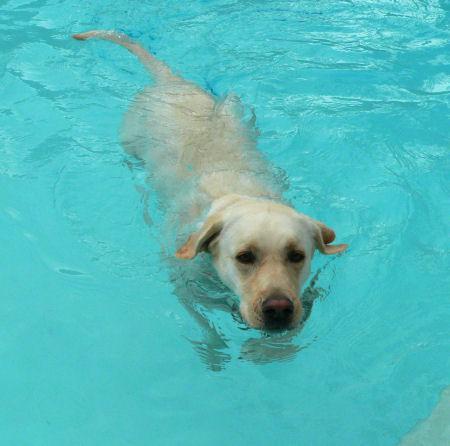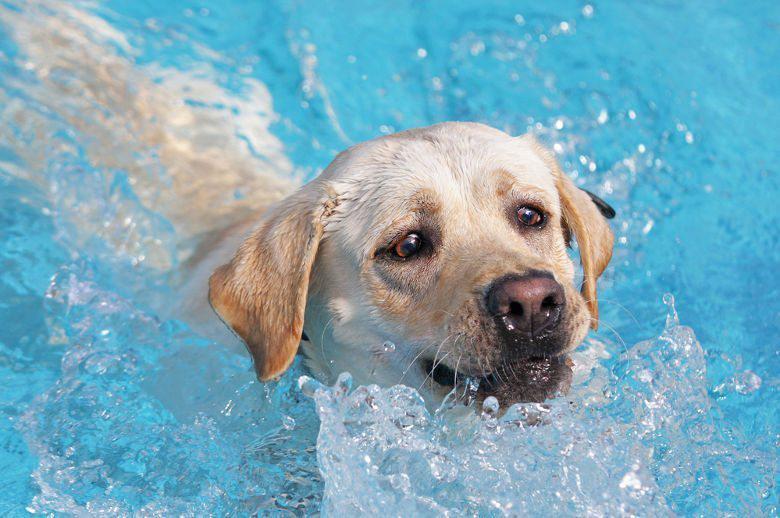The first image is the image on the left, the second image is the image on the right. Analyze the images presented: Is the assertion "Each image shows a blond labrador retriever in the blue water of a swimming pool, and at least one dog is swimming forward." valid? Answer yes or no. Yes. The first image is the image on the left, the second image is the image on the right. For the images shown, is this caption "Two dogs are swimming through water up to their chin." true? Answer yes or no. Yes. 